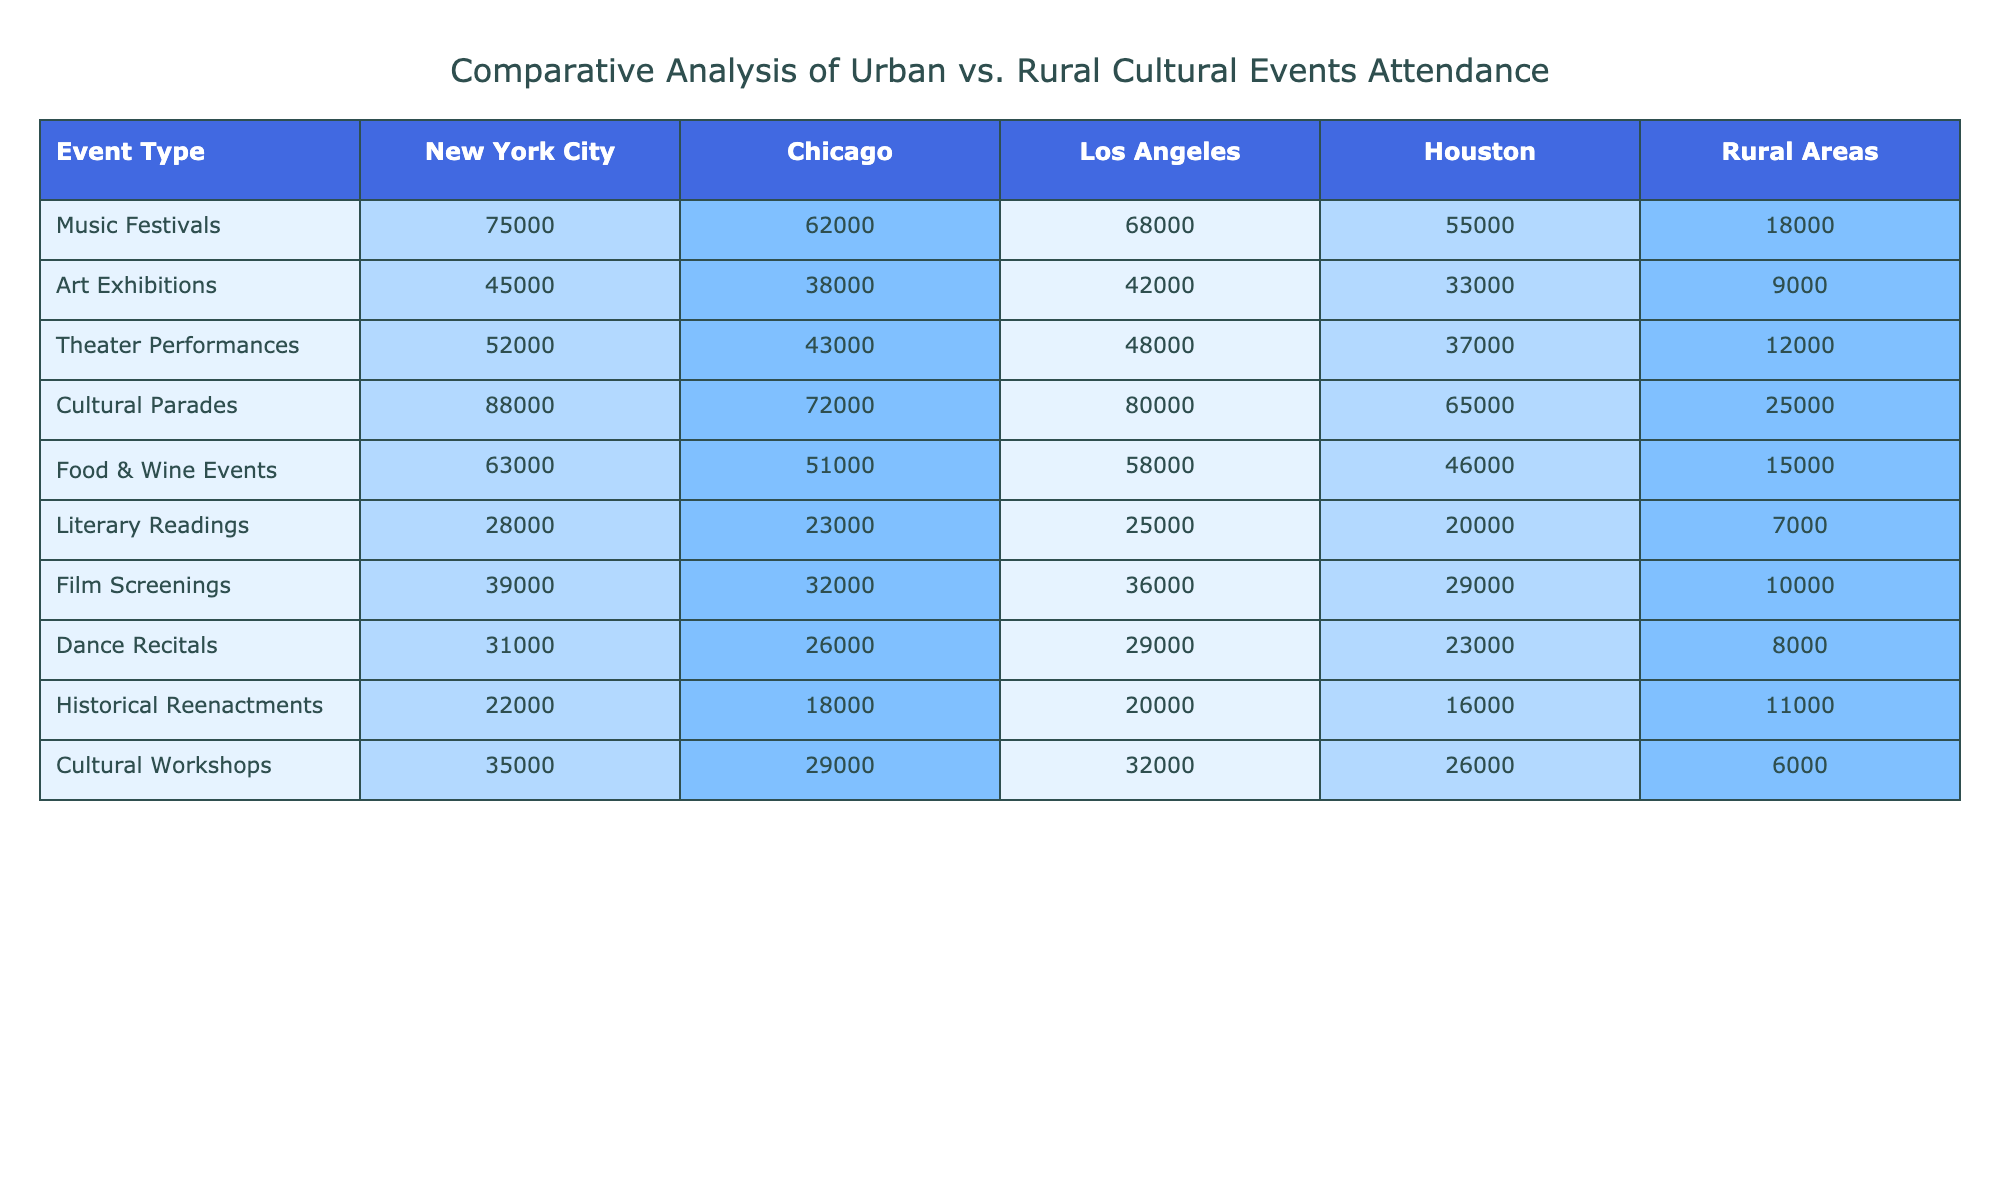What is the attendance for Cultural Parades in New York City? The table shows the attendance for Cultural Parades in New York City as 88,000.
Answer: 88,000 Which city has the highest attendance for Music Festivals? By comparing the values in the Music Festivals row, New York City has the highest attendance with 75,000.
Answer: New York City What is the total attendance for Food & Wine Events across all cities? To find the total, we add the values: 63,000 (NYC) + 51,000 (Chicago) + 58,000 (Los Angeles) + 46,000 (Houston) + 15,000 (Rural Areas) = 233,000.
Answer: 233,000 Is the attendance for Literary Readings higher in urban areas compared to rural areas? The table shows 28,000 (NYC) + 23,000 (Chicago) + 25,000 (Los Angeles) + 20,000 (Houston) = 96,000 for urban areas versus 7,000 for rural areas, confirming that urban attendance is higher.
Answer: Yes What is the average attendance for Cultural Workshops across all cities? Adding the attendance for Cultural Workshops gives: 35,000 (NYC) + 29,000 (Chicago) + 32,000 (Los Angeles) + 26,000 (Houston) + 6,000 (Rural Areas) = 128,000. There are 5 entries, so the average is 128,000 / 5 = 25,600.
Answer: 25,600 Which event type has the lowest attendance in rural areas? By checking the Rural Areas column, the lowest event type listed is Cultural Workshops with an attendance of 6,000.
Answer: Cultural Workshops If we look at the difference between the highest and lowest attendance for Theater Performances among all cities, what would that be? The highest attendance is 52,000 (NYC), and the lowest is 12,000 (Rural Areas). The difference is 52,000 - 12,000 = 40,000.
Answer: 40,000 How many more Cultural Parades attendees are there in Los Angeles compared to Houston? The attendance for Cultural Parades is 80,000 (Los Angeles) versus 65,000 (Houston). The difference is 80,000 - 65,000 = 15,000.
Answer: 15,000 What is the total cultural event attendance for Chicago? For Chicago, we sum the attendance figures: 62,000 (Music Festivals) + 38,000 (Art Exhibitions) + 43,000 (Theater Performances) + 72,000 (Cultural Parades) + 51,000 (Food & Wine Events) + 23,000 (Literary Readings) + 32,000 (Film Screenings) + 26,000 (Dance Recitals) + 18,000 (Historical Reenactments) + 29,000 (Cultural Workshops) = 422,000.
Answer: 422,000 Is Houston's attendance for Food & Wine Events higher than for Art Exhibitions? Houston has 46,000 for Food & Wine Events and 33,000 for Art Exhibitions. Since 46,000 > 33,000, it confirms that attendance for Food & Wine Events is indeed higher.
Answer: Yes 